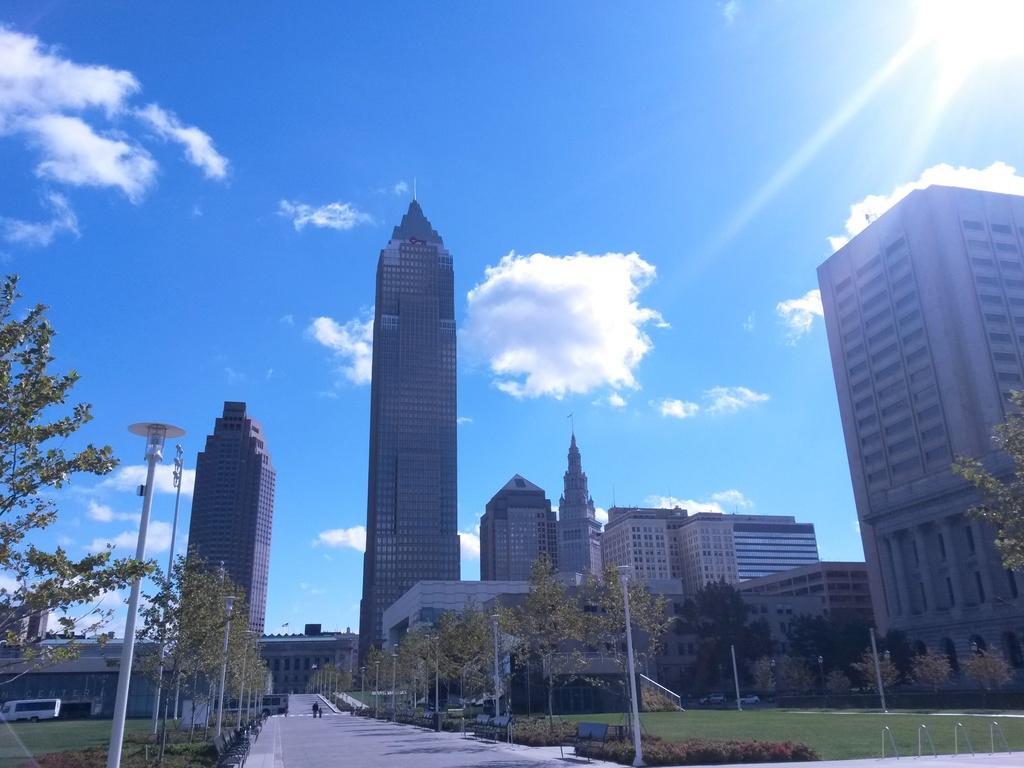Please provide a concise description of this image. On the left side, there are poles, trees, plants and grass on the ground. In the middle, there is road. On the right side, there are poles, trees, plants and grass on the ground. In the background, there are buildings, vehicles on the road and there are clouds in the blue sky. 